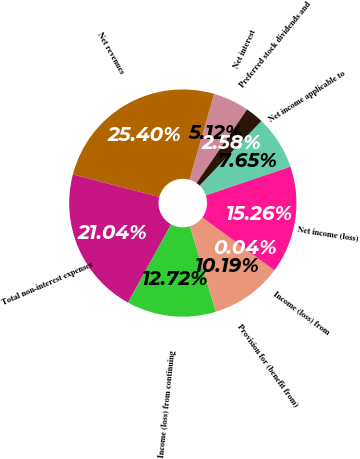Convert chart. <chart><loc_0><loc_0><loc_500><loc_500><pie_chart><fcel>Net interest<fcel>Net revenues<fcel>Total non-interest expenses<fcel>Income (loss) from continuing<fcel>Provision for (benefit from)<fcel>Income (loss) from<fcel>Net income (loss)<fcel>Net income applicable to<fcel>Preferred stock dividends and<nl><fcel>5.12%<fcel>25.4%<fcel>21.04%<fcel>12.72%<fcel>10.19%<fcel>0.04%<fcel>15.26%<fcel>7.65%<fcel>2.58%<nl></chart> 